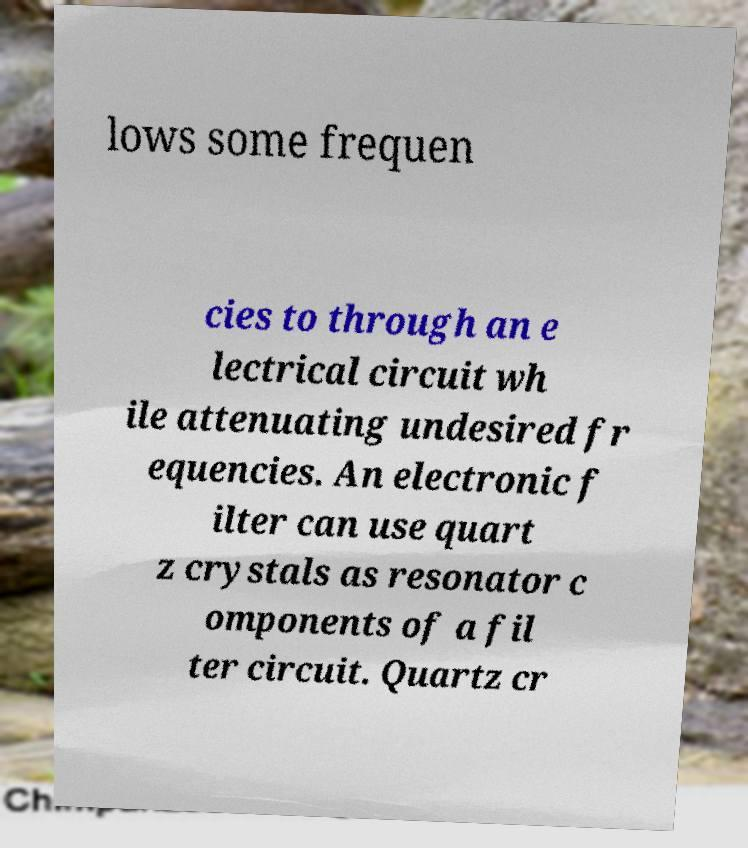Please identify and transcribe the text found in this image. lows some frequen cies to through an e lectrical circuit wh ile attenuating undesired fr equencies. An electronic f ilter can use quart z crystals as resonator c omponents of a fil ter circuit. Quartz cr 